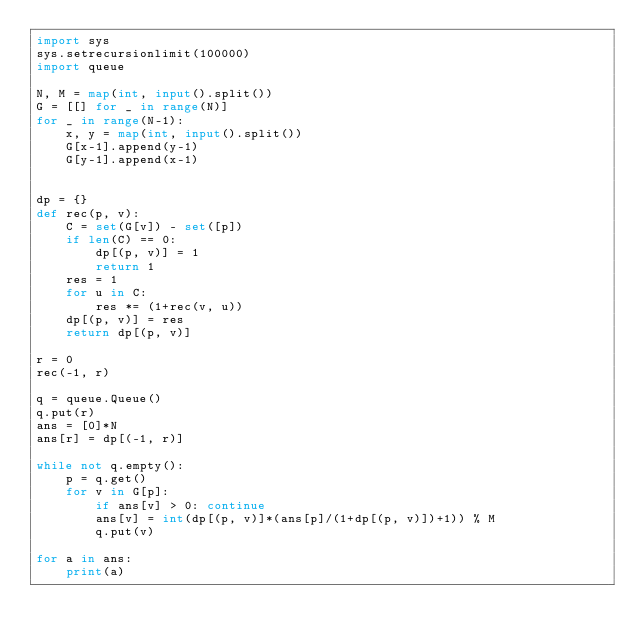Convert code to text. <code><loc_0><loc_0><loc_500><loc_500><_Python_>import sys 
sys.setrecursionlimit(100000) 
import queue

N, M = map(int, input().split())
G = [[] for _ in range(N)]
for _ in range(N-1):
    x, y = map(int, input().split())
    G[x-1].append(y-1)
    G[y-1].append(x-1)


dp = {}
def rec(p, v):
    C = set(G[v]) - set([p])
    if len(C) == 0:
        dp[(p, v)] = 1
        return 1
    res = 1
    for u in C:
        res *= (1+rec(v, u))
    dp[(p, v)] = res
    return dp[(p, v)]

r = 0       
rec(-1, r)

q = queue.Queue()
q.put(r)
ans = [0]*N
ans[r] = dp[(-1, r)]

while not q.empty():
    p = q.get()
    for v in G[p]:
        if ans[v] > 0: continue
        ans[v] = int(dp[(p, v)]*(ans[p]/(1+dp[(p, v)])+1)) % M
        q.put(v)

for a in ans:
    print(a)
</code> 